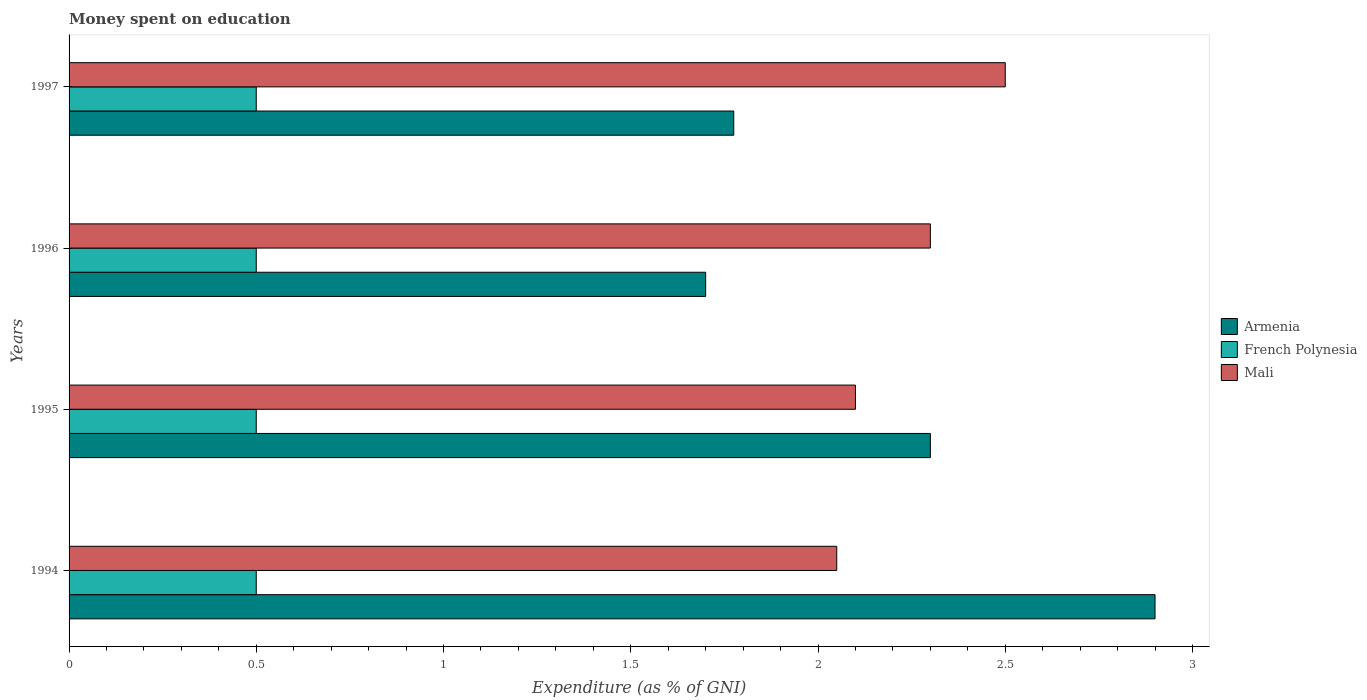How many different coloured bars are there?
Your answer should be very brief. 3. Are the number of bars per tick equal to the number of legend labels?
Provide a short and direct response. Yes. Are the number of bars on each tick of the Y-axis equal?
Offer a terse response. Yes. How many bars are there on the 4th tick from the top?
Your answer should be compact. 3. What is the label of the 1st group of bars from the top?
Give a very brief answer. 1997. What is the amount of money spent on education in Armenia in 1997?
Offer a very short reply. 1.77. Across all years, what is the maximum amount of money spent on education in French Polynesia?
Your answer should be very brief. 0.5. Across all years, what is the minimum amount of money spent on education in Armenia?
Make the answer very short. 1.7. In which year was the amount of money spent on education in Armenia maximum?
Provide a succinct answer. 1994. In which year was the amount of money spent on education in Mali minimum?
Offer a very short reply. 1994. What is the total amount of money spent on education in French Polynesia in the graph?
Your answer should be compact. 2. What is the difference between the amount of money spent on education in French Polynesia in 1995 and that in 1997?
Ensure brevity in your answer.  0. What is the difference between the amount of money spent on education in French Polynesia in 1995 and the amount of money spent on education in Mali in 1997?
Offer a terse response. -2. What is the average amount of money spent on education in Armenia per year?
Ensure brevity in your answer.  2.17. In the year 1995, what is the difference between the amount of money spent on education in Armenia and amount of money spent on education in Mali?
Offer a terse response. 0.2. In how many years, is the amount of money spent on education in French Polynesia greater than 0.5 %?
Give a very brief answer. 0. What is the ratio of the amount of money spent on education in Armenia in 1996 to that in 1997?
Offer a terse response. 0.96. What is the difference between the highest and the second highest amount of money spent on education in Armenia?
Keep it short and to the point. 0.6. What is the difference between the highest and the lowest amount of money spent on education in Mali?
Your answer should be compact. 0.45. Is the sum of the amount of money spent on education in Mali in 1994 and 1997 greater than the maximum amount of money spent on education in French Polynesia across all years?
Ensure brevity in your answer.  Yes. What does the 2nd bar from the top in 1997 represents?
Keep it short and to the point. French Polynesia. What does the 2nd bar from the bottom in 1995 represents?
Make the answer very short. French Polynesia. Is it the case that in every year, the sum of the amount of money spent on education in French Polynesia and amount of money spent on education in Armenia is greater than the amount of money spent on education in Mali?
Provide a short and direct response. No. Are all the bars in the graph horizontal?
Your response must be concise. Yes. What is the difference between two consecutive major ticks on the X-axis?
Your answer should be compact. 0.5. How many legend labels are there?
Give a very brief answer. 3. How are the legend labels stacked?
Ensure brevity in your answer.  Vertical. What is the title of the graph?
Give a very brief answer. Money spent on education. What is the label or title of the X-axis?
Your answer should be very brief. Expenditure (as % of GNI). What is the label or title of the Y-axis?
Ensure brevity in your answer.  Years. What is the Expenditure (as % of GNI) in Armenia in 1994?
Keep it short and to the point. 2.9. What is the Expenditure (as % of GNI) in French Polynesia in 1994?
Keep it short and to the point. 0.5. What is the Expenditure (as % of GNI) of Mali in 1994?
Your response must be concise. 2.05. What is the Expenditure (as % of GNI) of Armenia in 1995?
Offer a very short reply. 2.3. What is the Expenditure (as % of GNI) in French Polynesia in 1995?
Offer a very short reply. 0.5. What is the Expenditure (as % of GNI) in Armenia in 1996?
Offer a terse response. 1.7. What is the Expenditure (as % of GNI) of French Polynesia in 1996?
Provide a succinct answer. 0.5. What is the Expenditure (as % of GNI) of Mali in 1996?
Give a very brief answer. 2.3. What is the Expenditure (as % of GNI) of Armenia in 1997?
Keep it short and to the point. 1.77. What is the Expenditure (as % of GNI) of French Polynesia in 1997?
Provide a succinct answer. 0.5. What is the Expenditure (as % of GNI) in Mali in 1997?
Ensure brevity in your answer.  2.5. Across all years, what is the maximum Expenditure (as % of GNI) in Armenia?
Make the answer very short. 2.9. Across all years, what is the maximum Expenditure (as % of GNI) in French Polynesia?
Provide a short and direct response. 0.5. Across all years, what is the maximum Expenditure (as % of GNI) of Mali?
Your response must be concise. 2.5. Across all years, what is the minimum Expenditure (as % of GNI) in Armenia?
Your answer should be very brief. 1.7. Across all years, what is the minimum Expenditure (as % of GNI) in French Polynesia?
Give a very brief answer. 0.5. Across all years, what is the minimum Expenditure (as % of GNI) of Mali?
Ensure brevity in your answer.  2.05. What is the total Expenditure (as % of GNI) of Armenia in the graph?
Ensure brevity in your answer.  8.68. What is the total Expenditure (as % of GNI) of French Polynesia in the graph?
Provide a short and direct response. 2. What is the total Expenditure (as % of GNI) of Mali in the graph?
Keep it short and to the point. 8.95. What is the difference between the Expenditure (as % of GNI) in French Polynesia in 1994 and that in 1996?
Provide a succinct answer. 0. What is the difference between the Expenditure (as % of GNI) in Mali in 1994 and that in 1996?
Provide a short and direct response. -0.25. What is the difference between the Expenditure (as % of GNI) of Armenia in 1994 and that in 1997?
Offer a terse response. 1.12. What is the difference between the Expenditure (as % of GNI) of Mali in 1994 and that in 1997?
Your answer should be very brief. -0.45. What is the difference between the Expenditure (as % of GNI) of Armenia in 1995 and that in 1996?
Provide a succinct answer. 0.6. What is the difference between the Expenditure (as % of GNI) in French Polynesia in 1995 and that in 1996?
Provide a short and direct response. 0. What is the difference between the Expenditure (as % of GNI) in Armenia in 1995 and that in 1997?
Offer a very short reply. 0.53. What is the difference between the Expenditure (as % of GNI) of French Polynesia in 1995 and that in 1997?
Your response must be concise. 0. What is the difference between the Expenditure (as % of GNI) of Armenia in 1996 and that in 1997?
Give a very brief answer. -0.07. What is the difference between the Expenditure (as % of GNI) of Armenia in 1994 and the Expenditure (as % of GNI) of French Polynesia in 1995?
Your answer should be compact. 2.4. What is the difference between the Expenditure (as % of GNI) in French Polynesia in 1994 and the Expenditure (as % of GNI) in Mali in 1995?
Your answer should be compact. -1.6. What is the difference between the Expenditure (as % of GNI) in Armenia in 1994 and the Expenditure (as % of GNI) in French Polynesia in 1996?
Make the answer very short. 2.4. What is the difference between the Expenditure (as % of GNI) in French Polynesia in 1994 and the Expenditure (as % of GNI) in Mali in 1996?
Your answer should be very brief. -1.8. What is the difference between the Expenditure (as % of GNI) of Armenia in 1994 and the Expenditure (as % of GNI) of French Polynesia in 1997?
Provide a succinct answer. 2.4. What is the difference between the Expenditure (as % of GNI) of French Polynesia in 1994 and the Expenditure (as % of GNI) of Mali in 1997?
Offer a terse response. -2. What is the difference between the Expenditure (as % of GNI) in Armenia in 1995 and the Expenditure (as % of GNI) in French Polynesia in 1996?
Make the answer very short. 1.8. What is the difference between the Expenditure (as % of GNI) in French Polynesia in 1995 and the Expenditure (as % of GNI) in Mali in 1996?
Give a very brief answer. -1.8. What is the difference between the Expenditure (as % of GNI) in Armenia in 1995 and the Expenditure (as % of GNI) in French Polynesia in 1997?
Offer a terse response. 1.8. What is the difference between the Expenditure (as % of GNI) of French Polynesia in 1995 and the Expenditure (as % of GNI) of Mali in 1997?
Your response must be concise. -2. What is the difference between the Expenditure (as % of GNI) in Armenia in 1996 and the Expenditure (as % of GNI) in French Polynesia in 1997?
Your answer should be compact. 1.2. What is the difference between the Expenditure (as % of GNI) of Armenia in 1996 and the Expenditure (as % of GNI) of Mali in 1997?
Offer a very short reply. -0.8. What is the difference between the Expenditure (as % of GNI) in French Polynesia in 1996 and the Expenditure (as % of GNI) in Mali in 1997?
Offer a terse response. -2. What is the average Expenditure (as % of GNI) of Armenia per year?
Make the answer very short. 2.17. What is the average Expenditure (as % of GNI) of French Polynesia per year?
Ensure brevity in your answer.  0.5. What is the average Expenditure (as % of GNI) in Mali per year?
Keep it short and to the point. 2.24. In the year 1994, what is the difference between the Expenditure (as % of GNI) of Armenia and Expenditure (as % of GNI) of French Polynesia?
Your response must be concise. 2.4. In the year 1994, what is the difference between the Expenditure (as % of GNI) of French Polynesia and Expenditure (as % of GNI) of Mali?
Your response must be concise. -1.55. In the year 1995, what is the difference between the Expenditure (as % of GNI) of Armenia and Expenditure (as % of GNI) of French Polynesia?
Your answer should be compact. 1.8. In the year 1995, what is the difference between the Expenditure (as % of GNI) in Armenia and Expenditure (as % of GNI) in Mali?
Keep it short and to the point. 0.2. In the year 1995, what is the difference between the Expenditure (as % of GNI) in French Polynesia and Expenditure (as % of GNI) in Mali?
Your answer should be compact. -1.6. In the year 1996, what is the difference between the Expenditure (as % of GNI) in Armenia and Expenditure (as % of GNI) in French Polynesia?
Provide a short and direct response. 1.2. In the year 1996, what is the difference between the Expenditure (as % of GNI) of French Polynesia and Expenditure (as % of GNI) of Mali?
Offer a very short reply. -1.8. In the year 1997, what is the difference between the Expenditure (as % of GNI) of Armenia and Expenditure (as % of GNI) of French Polynesia?
Offer a terse response. 1.28. In the year 1997, what is the difference between the Expenditure (as % of GNI) in Armenia and Expenditure (as % of GNI) in Mali?
Your response must be concise. -0.72. In the year 1997, what is the difference between the Expenditure (as % of GNI) of French Polynesia and Expenditure (as % of GNI) of Mali?
Provide a short and direct response. -2. What is the ratio of the Expenditure (as % of GNI) of Armenia in 1994 to that in 1995?
Keep it short and to the point. 1.26. What is the ratio of the Expenditure (as % of GNI) of Mali in 1994 to that in 1995?
Offer a terse response. 0.98. What is the ratio of the Expenditure (as % of GNI) in Armenia in 1994 to that in 1996?
Provide a short and direct response. 1.71. What is the ratio of the Expenditure (as % of GNI) in Mali in 1994 to that in 1996?
Your answer should be very brief. 0.89. What is the ratio of the Expenditure (as % of GNI) of Armenia in 1994 to that in 1997?
Make the answer very short. 1.63. What is the ratio of the Expenditure (as % of GNI) in Mali in 1994 to that in 1997?
Give a very brief answer. 0.82. What is the ratio of the Expenditure (as % of GNI) in Armenia in 1995 to that in 1996?
Make the answer very short. 1.35. What is the ratio of the Expenditure (as % of GNI) of French Polynesia in 1995 to that in 1996?
Ensure brevity in your answer.  1. What is the ratio of the Expenditure (as % of GNI) in Mali in 1995 to that in 1996?
Your answer should be very brief. 0.91. What is the ratio of the Expenditure (as % of GNI) of Armenia in 1995 to that in 1997?
Offer a very short reply. 1.3. What is the ratio of the Expenditure (as % of GNI) of French Polynesia in 1995 to that in 1997?
Keep it short and to the point. 1. What is the ratio of the Expenditure (as % of GNI) of Mali in 1995 to that in 1997?
Give a very brief answer. 0.84. What is the ratio of the Expenditure (as % of GNI) in Armenia in 1996 to that in 1997?
Your answer should be very brief. 0.96. What is the ratio of the Expenditure (as % of GNI) of Mali in 1996 to that in 1997?
Offer a terse response. 0.92. What is the difference between the highest and the second highest Expenditure (as % of GNI) of Mali?
Your response must be concise. 0.2. What is the difference between the highest and the lowest Expenditure (as % of GNI) of Armenia?
Offer a terse response. 1.2. What is the difference between the highest and the lowest Expenditure (as % of GNI) in Mali?
Ensure brevity in your answer.  0.45. 